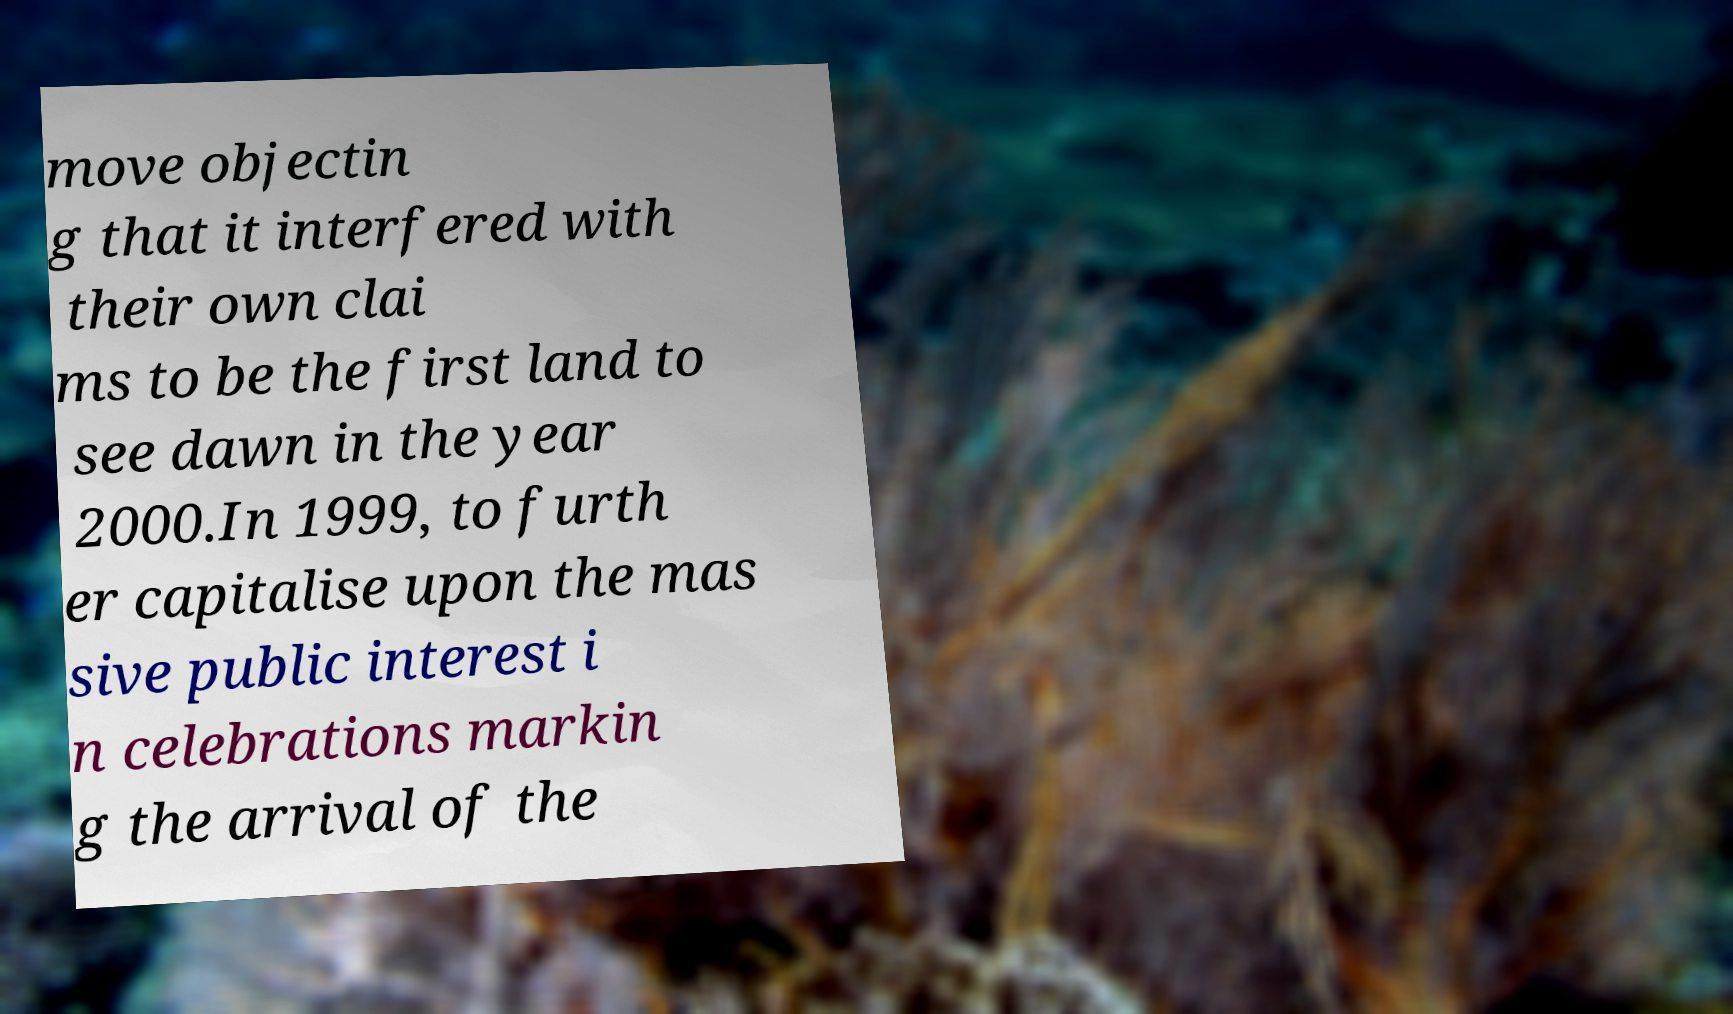Could you assist in decoding the text presented in this image and type it out clearly? move objectin g that it interfered with their own clai ms to be the first land to see dawn in the year 2000.In 1999, to furth er capitalise upon the mas sive public interest i n celebrations markin g the arrival of the 